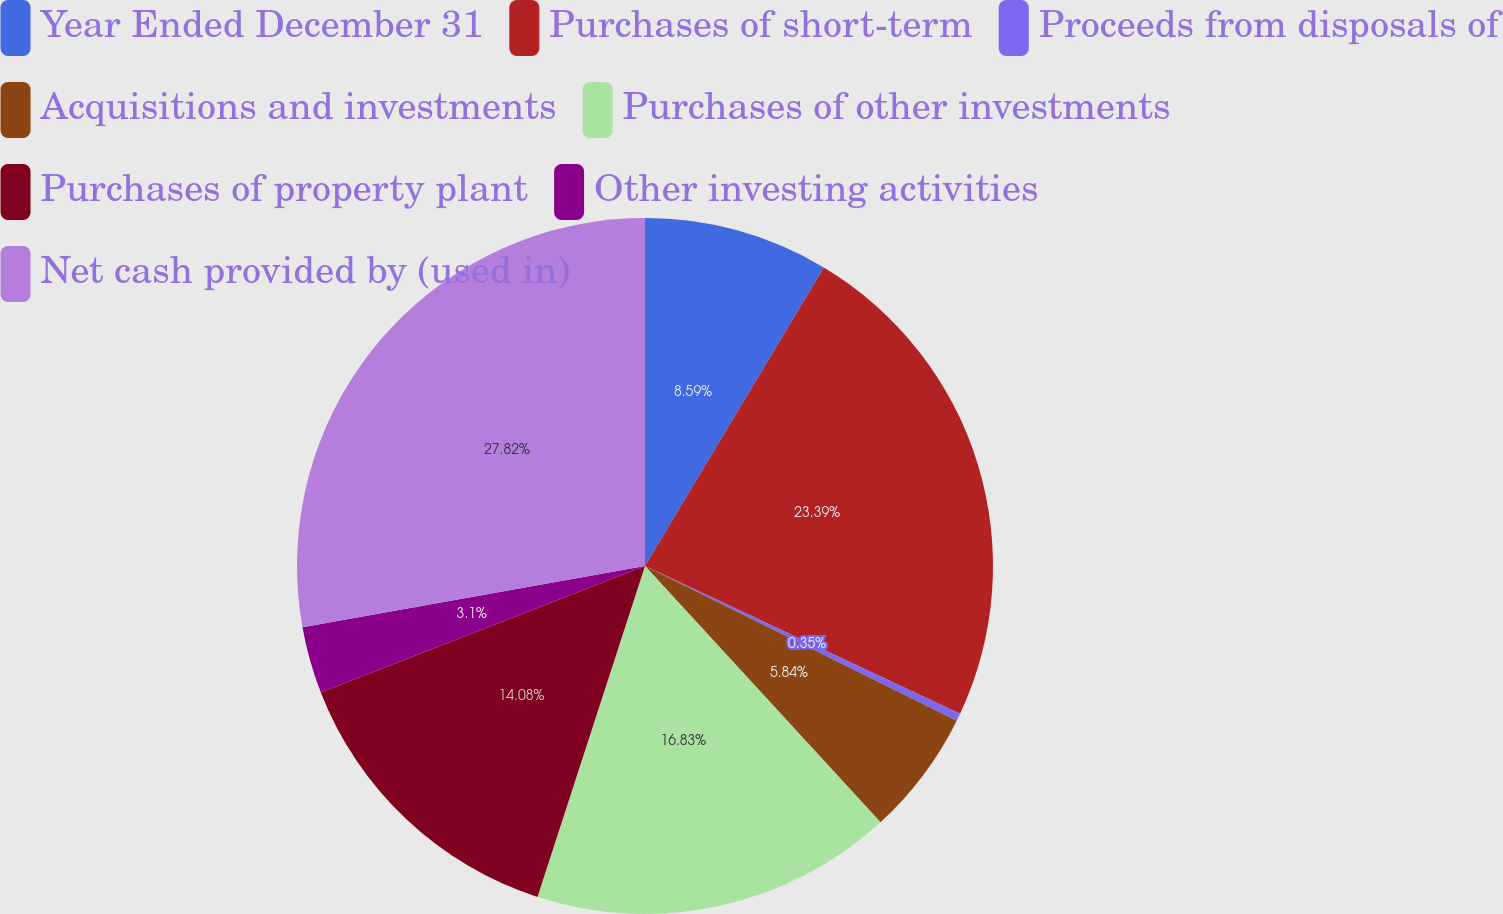Convert chart. <chart><loc_0><loc_0><loc_500><loc_500><pie_chart><fcel>Year Ended December 31<fcel>Purchases of short-term<fcel>Proceeds from disposals of<fcel>Acquisitions and investments<fcel>Purchases of other investments<fcel>Purchases of property plant<fcel>Other investing activities<fcel>Net cash provided by (used in)<nl><fcel>8.59%<fcel>23.39%<fcel>0.35%<fcel>5.84%<fcel>16.83%<fcel>14.08%<fcel>3.1%<fcel>27.82%<nl></chart> 